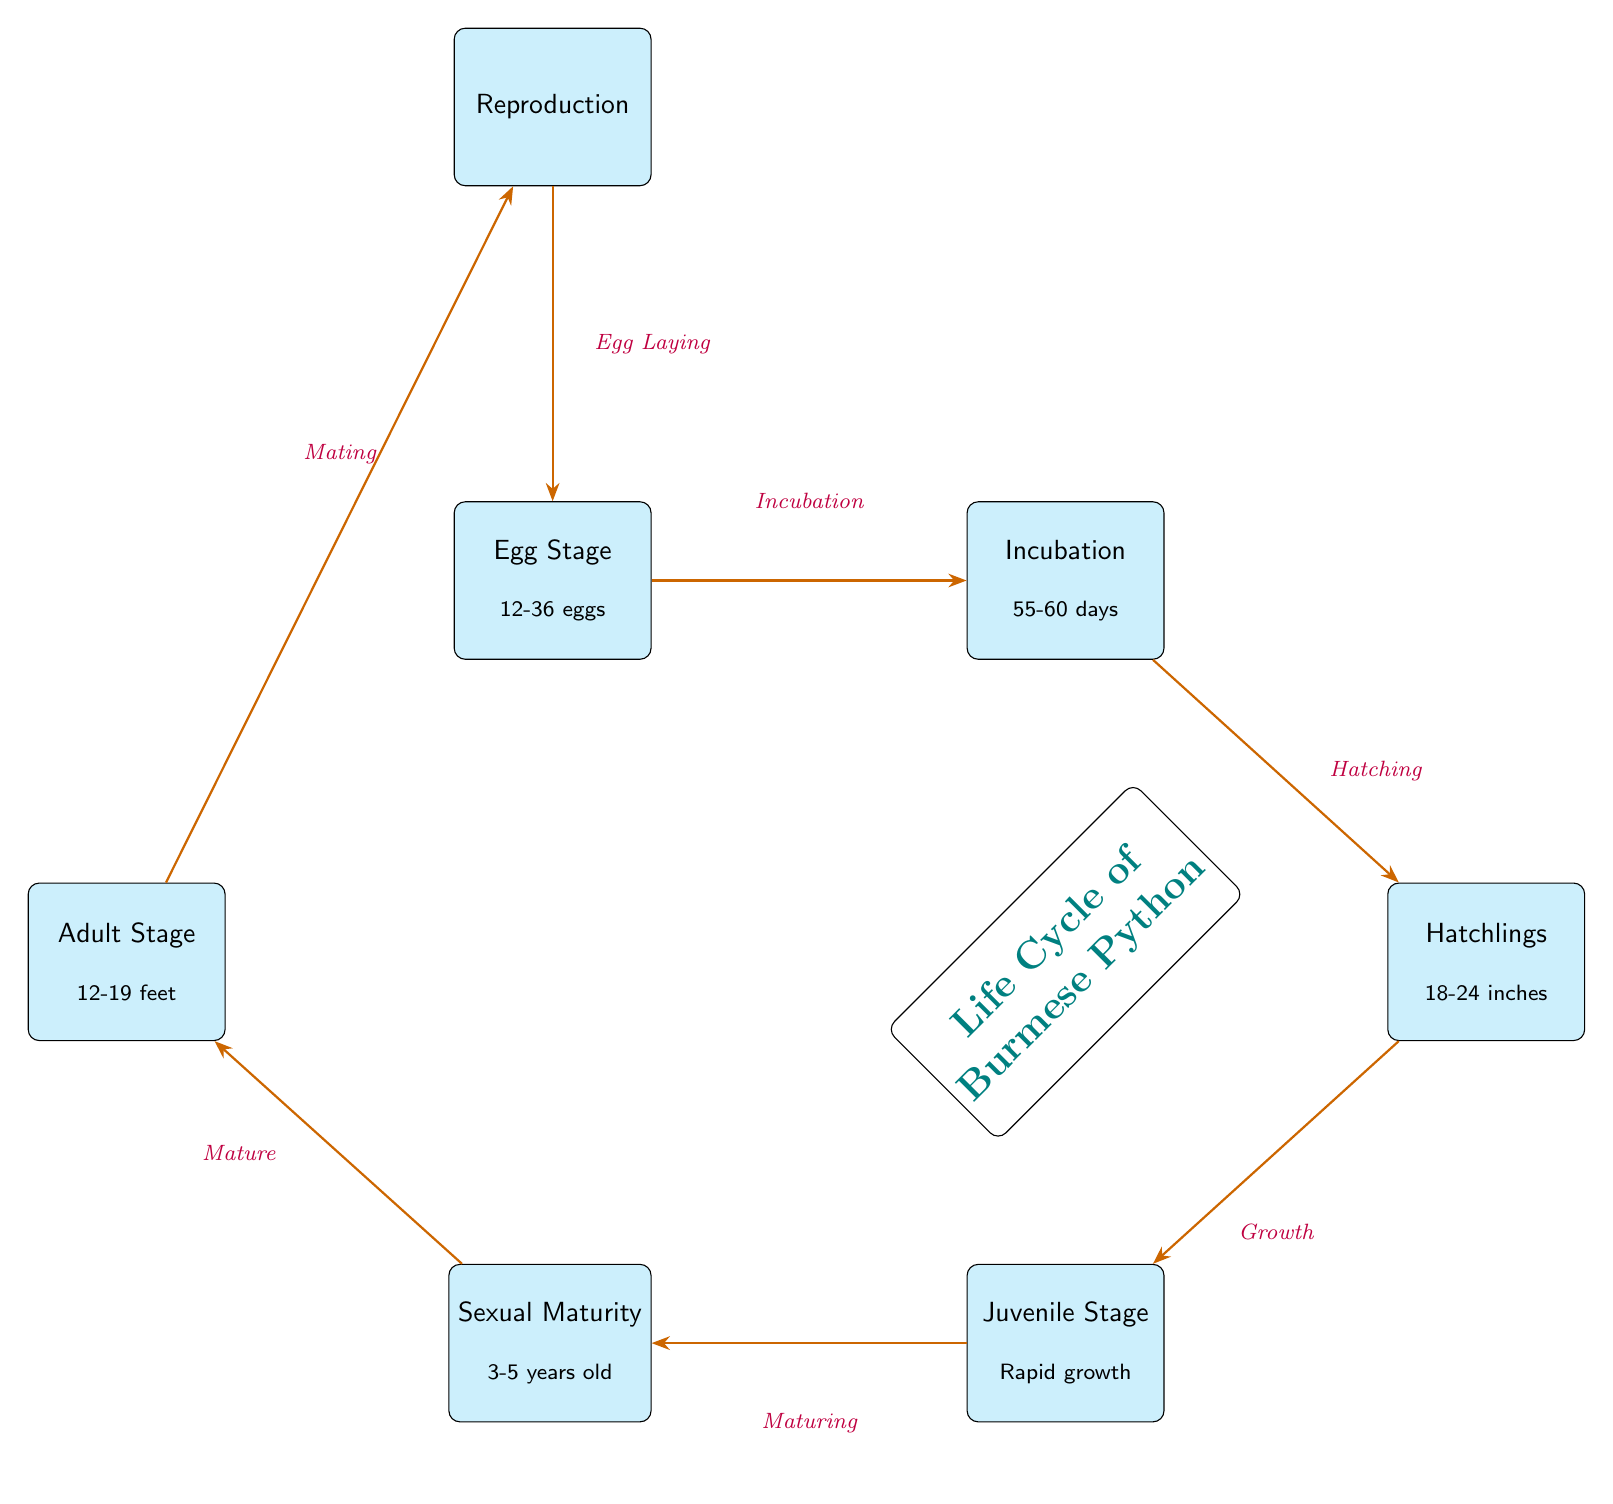What is the number of eggs laid in the Egg Stage? The diagram specifies that the Egg Stage consists of 12-36 eggs. Therefore, the answer is found directly adjacent to the Egg Stage node.
Answer: 12-36 eggs What follows the incubation period in the life cycle? The diagram shows an arrow from the incubation node leading to the hatchling node labeled "Hatching," indicating that hatching follows incubation.
Answer: Hatchlings What is the growth stage called after the hatchlings? After the hatchling stage, the diagram indicates that the next stage is the juvenile stage, evidenced by the labeling between those nodes.
Answer: Juvenile Stage At what age does sexual maturity occur? The diagram indicates that sexual maturity occurs at 3-5 years old, which is directly stated in the maturation node near the juvenile node.
Answer: 3-5 years old How long does the incubation last? The diagram specifically mentions that the incubation period lasts for 55-60 days, which is indicated within the incubation node description.
Answer: 55-60 days What is the maximum length of an adult Burmese Python? In the diagram, it is stated that the adult stage can reach lengths of 12-19 feet, which can be taken directly from the adult node.
Answer: 12-19 feet What process occurs at the adult stage in the cycle? The diagram indicates that at the adult stage, the process of mating occurs, as shown in the connecting arrow and labeled node transitioning from adult to reproduction.
Answer: Mating How is the life cycle of the Burmese Python described overall in the diagram? The diagram is labeled with a statement indicating "Life Cycle of Burmese Python," signifying that it encompasses the entire cycle visually represented.
Answer: Life Cycle of Burmese Python What is the transition between juvenile and sexual maturity? According to the diagram, the transition from the juvenile stage to sexual maturity is labeled as "Maturing," which is inscribed on the connecting arrow.
Answer: Maturing 